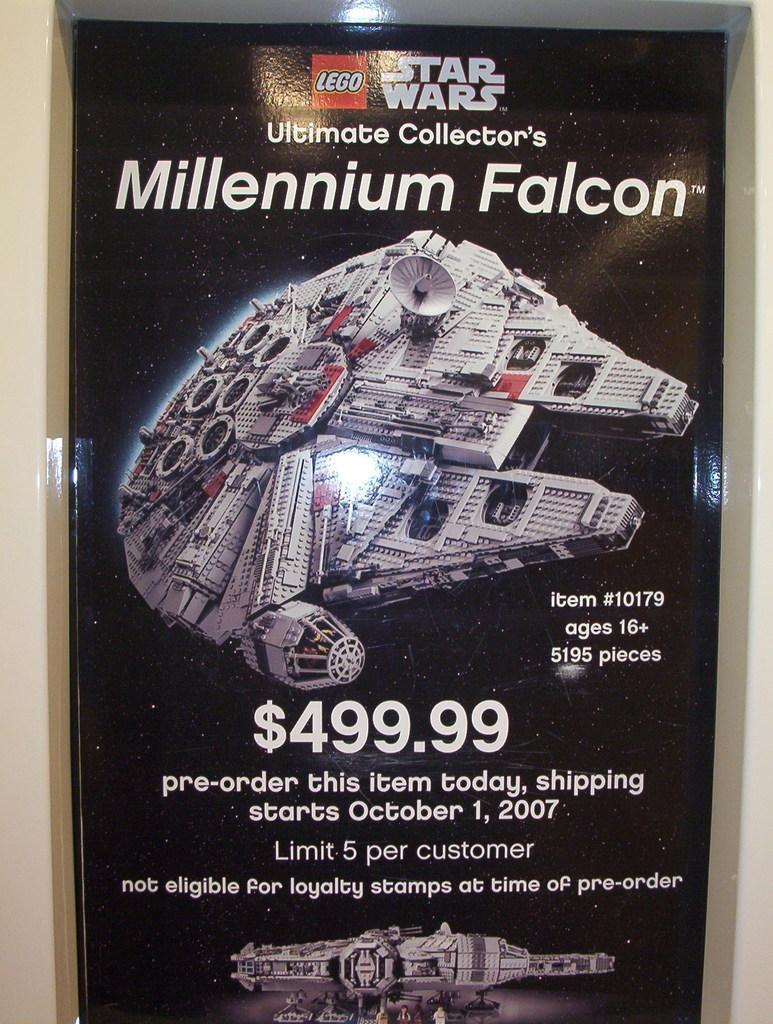<image>
Present a compact description of the photo's key features. A large advertisement for a Lego Star Wars toy spaceship called the Millennium Falcon. 